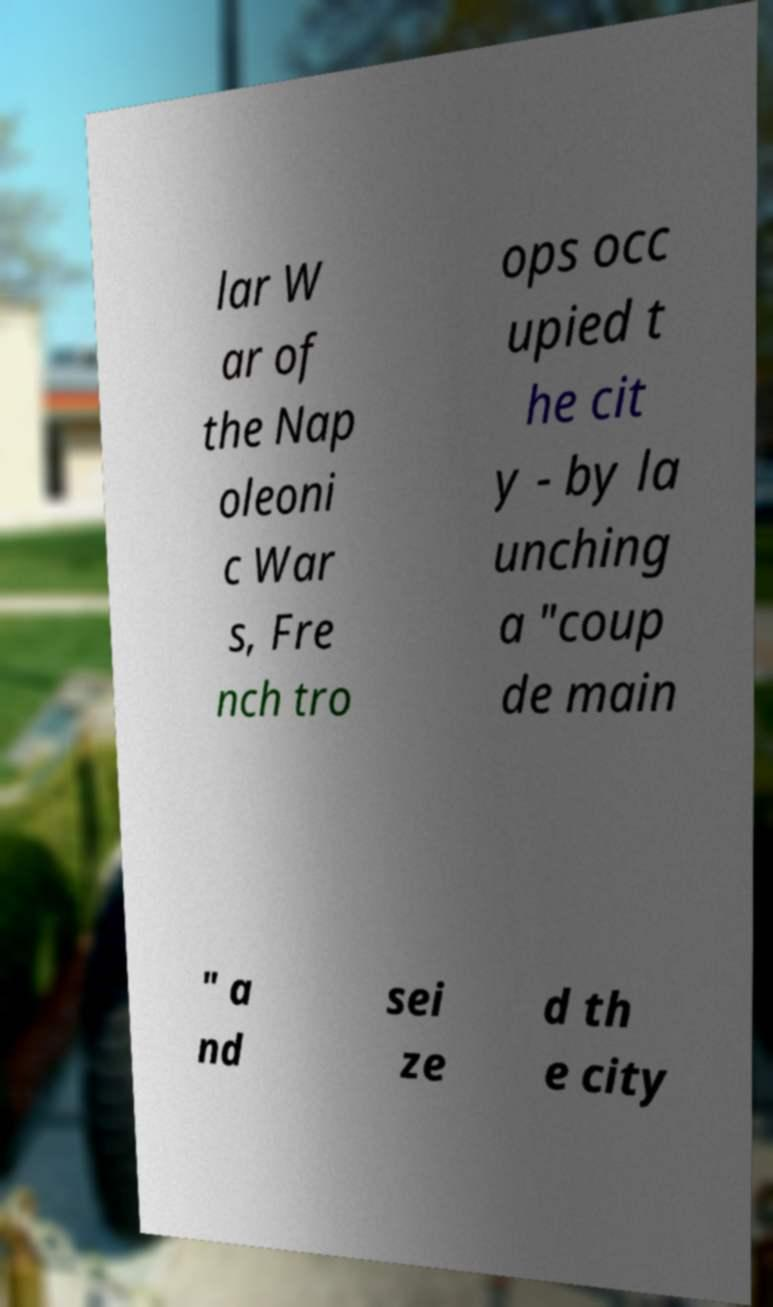Please read and relay the text visible in this image. What does it say? lar W ar of the Nap oleoni c War s, Fre nch tro ops occ upied t he cit y - by la unching a "coup de main " a nd sei ze d th e city 